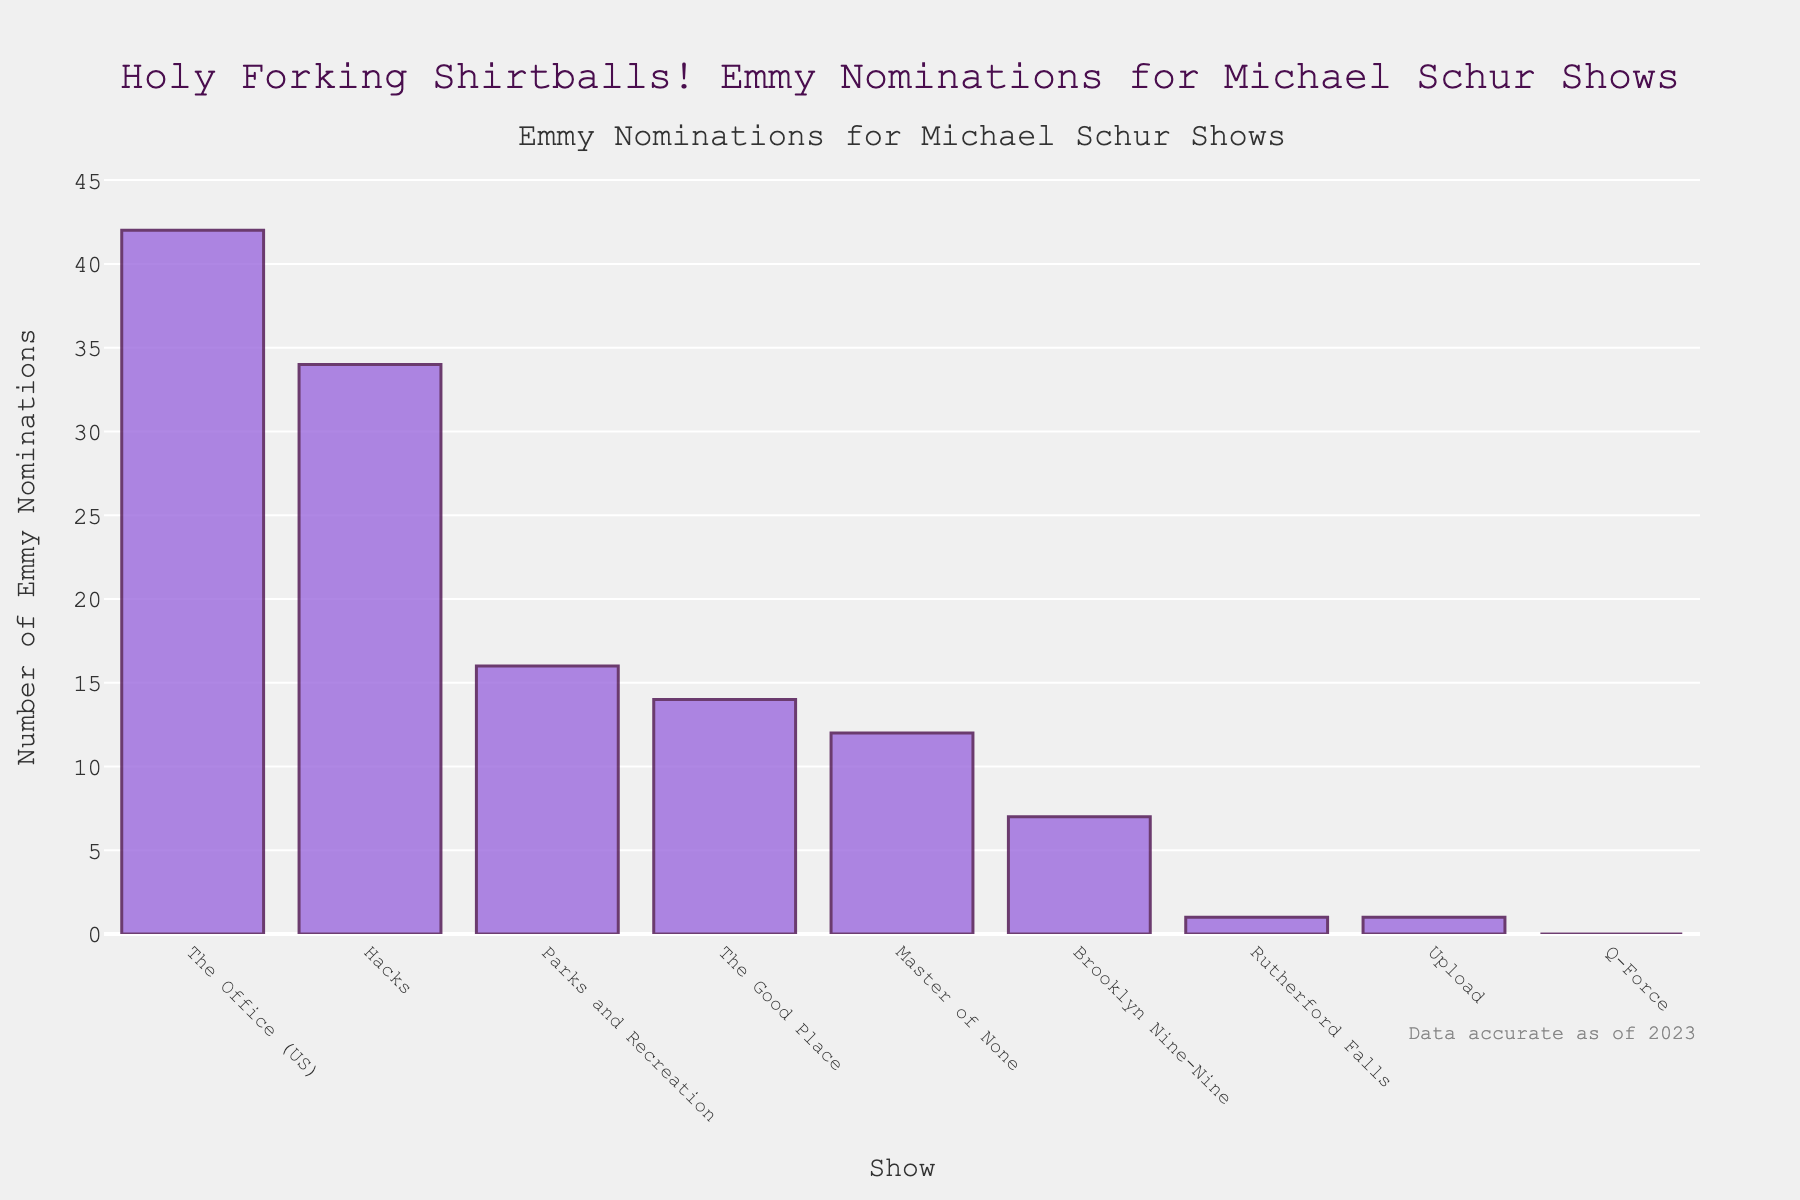Which show has the highest number of Emmy nominations? From the bar chart, the height of the bar for "The Office (US)" is the tallest, indicating it has the most Emmy nominations.
Answer: The Office (US) Which two shows combined have the same number of Emmy nominations as "Hacks"? Hacks has 34 nominations. The combination of "The Good Place" (14 nominations) and "Parks and Recreation" (16 nominations) gives a total of 30, which is closest but not equal. Considering "Master of None" (12 nominations) and "Brooklyn Nine-Nine" (7 nominations) also doesn't equal 34. The exact combination isn't possible with given data.
Answer: Not possible with given data Which show has received the least Emmy nominations? The bar for "Q-Force" is the shortest and represents 0 nominations.
Answer: Q-Force How many more nominations does "The Office (US)" have compared to "The Good Place"? The Office (US) has 42 nominations and The Good Place has 14. The difference is 42 - 14 = 28.
Answer: 28 What is the total number of Emmy nominations for all shows combined? Sum all nominations: 14 (The Good Place) + 16 (Parks and Recreation) + 7 (Brooklyn Nine-Nine) + 42 (The Office (US)) + 12 (Master of None) + 1 (Rutherford Falls) + 34 (Hacks) + 0 (Q-Force) + 1 (Upload) = 127.
Answer: 127 What is the median number of Emmy nominations for the listed shows? List nominations in ascending order: 0, 1, 1, 7, 12, 14, 16, 34, 42. The median, being the middle value of this ordered list, is 12 nominations (Master of None).
Answer: 12 How much taller is the bar for "Hacks" compared to "Brooklyn Nine-Nine"? Hacks has 34 nominations, and Brooklyn Nine-Nine has 7. The difference is 34 - 7 = 27.
Answer: 27 Is "The Good Place" above or below the average number of Emmy nominations represented in the chart? Average nominations: 127 total / 9 shows = 14.11. The Good Place has 14 nominations, which is slightly below the average.
Answer: Below Is "Upload" tied with any other show in terms of the number of Emmy nominations? Upload has 1 nomination. It ties with Rutherford Falls, which also has 1 nomination.
Answer: Yes Which show has exactly one-third of the nominations of "The Office (US)"? One-third of The Office (US)'s 42 nominations is 42 / 3 = 14. The Good Place has 14 nominations.
Answer: The Good Place 